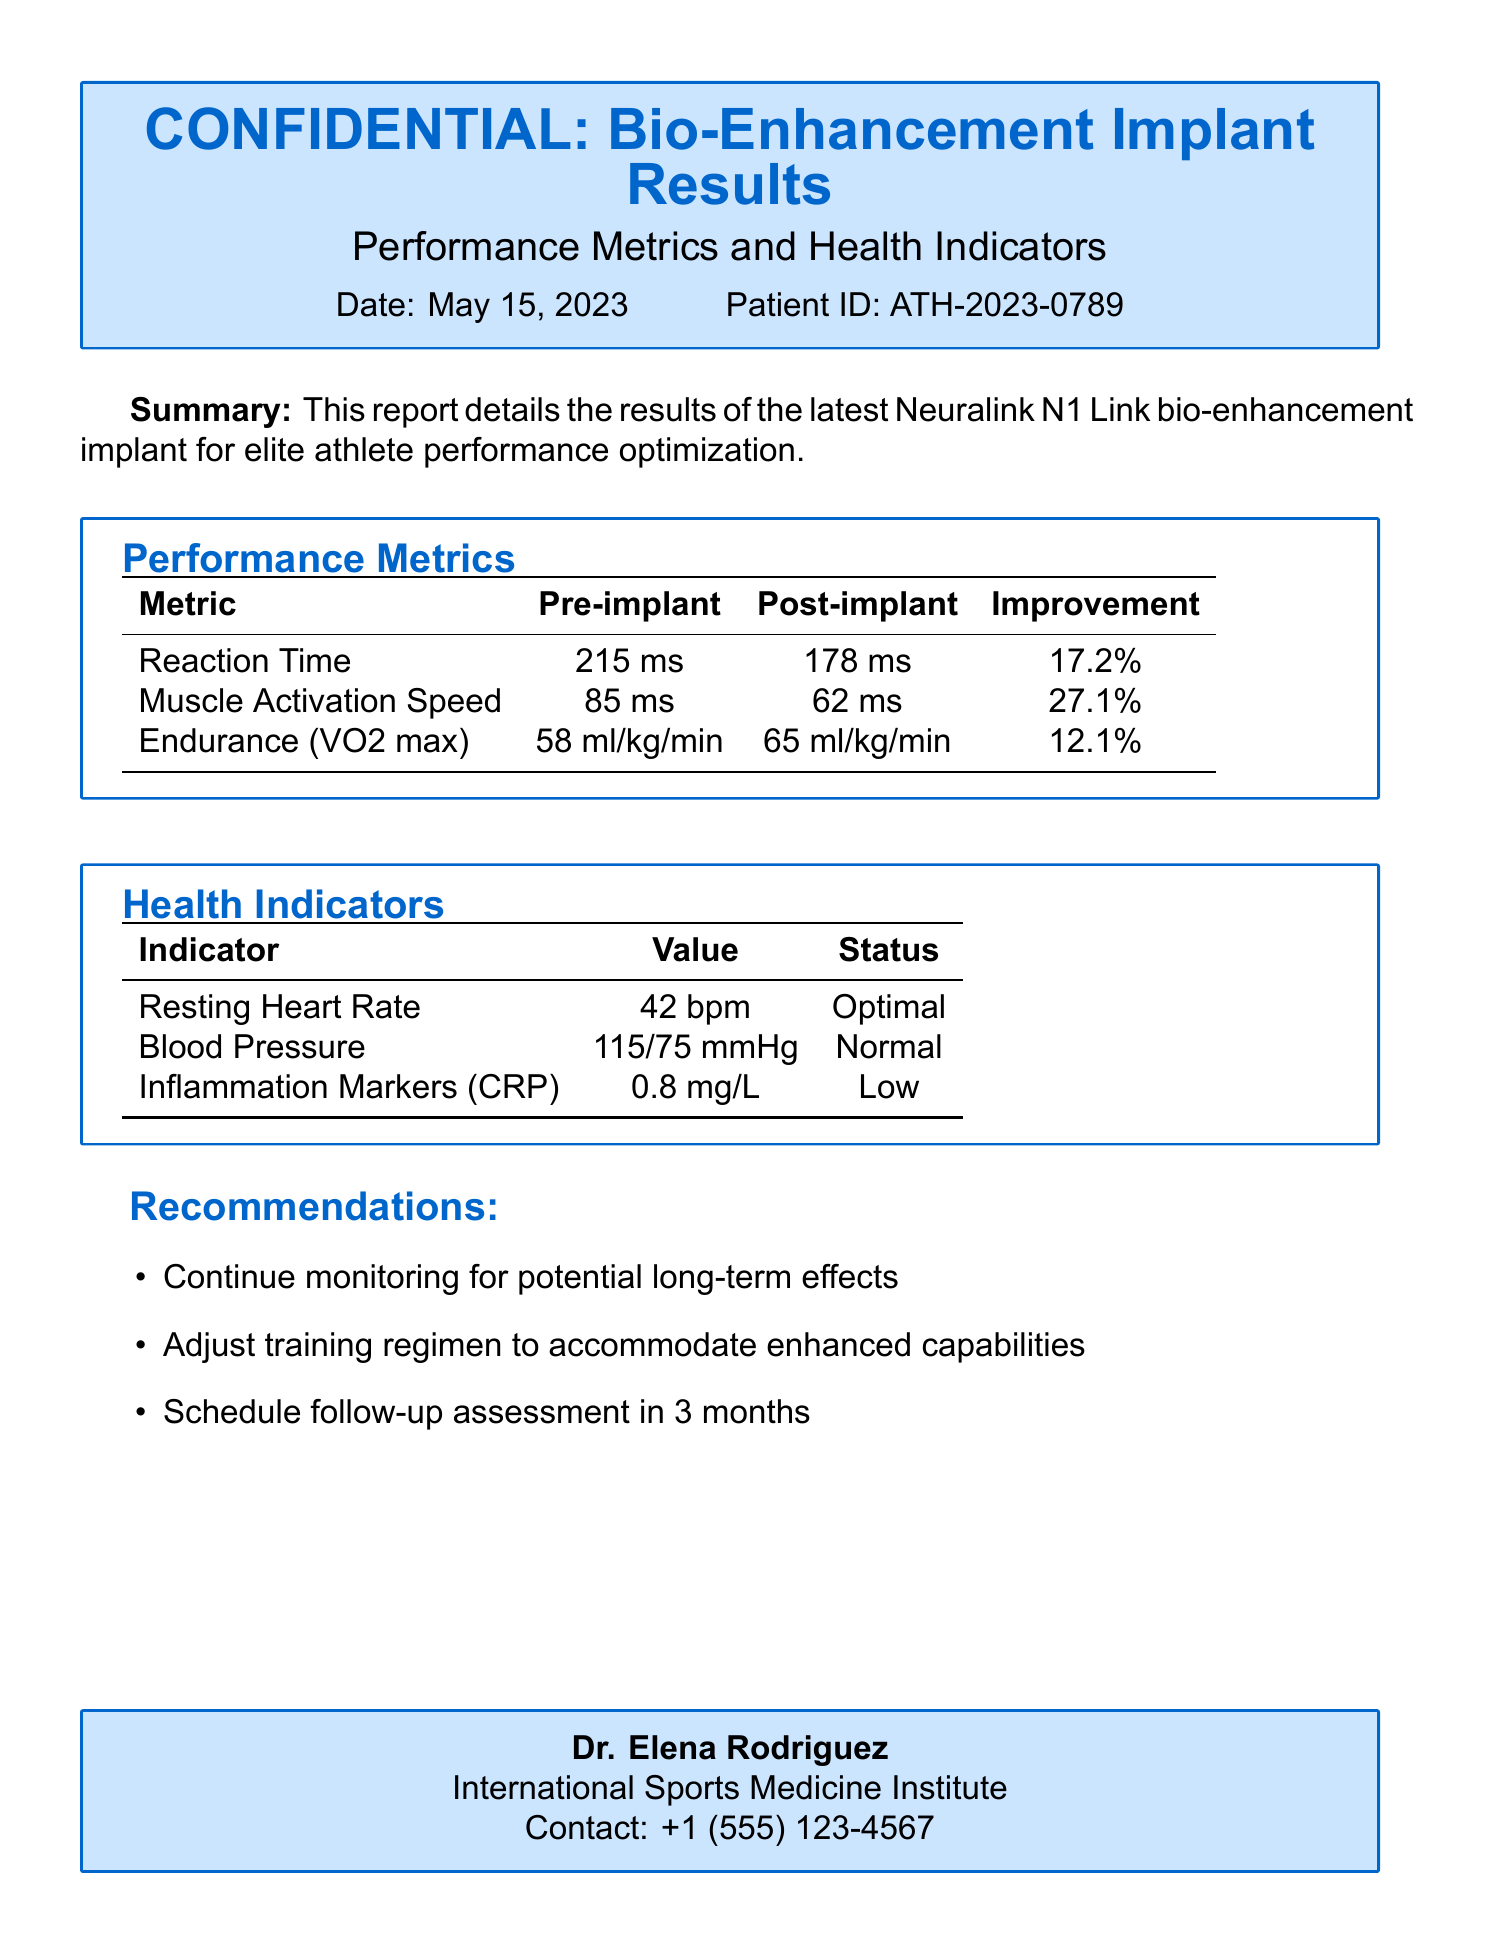What is the date of the report? The date of the report is indicated in the document header.
Answer: May 15, 2023 What is the patient ID? The patient ID is provided in the heading section of the document.
Answer: ATH-2023-0789 What was the improvement in reaction time? The improvement in reaction time is calculated from the pre-implant and post-implant metrics table.
Answer: 17.2% What is the post-implant endurance (VO2 max) value? The endurance value after the implant is found in the performance metrics section.
Answer: 65 ml/kg/min What is the status of the inflammation markers? The status of the inflammation markers is listed in the health indicators table.
Answer: Low What should be monitored according to the recommendations? The recommendations section suggests specific actions, one of which is monitoring.
Answer: Long-term effects What is the resting heart rate? The resting heart rate can be found in the health indicators section of the document.
Answer: 42 bpm What is the optimal status indicated for heart rate? The status for the resting heart rate is defined in the health indicators table.
Answer: Optimal What is the blood pressure reading? The blood pressure reading is displayed in the health indicators section.
Answer: 115/75 mmHg 